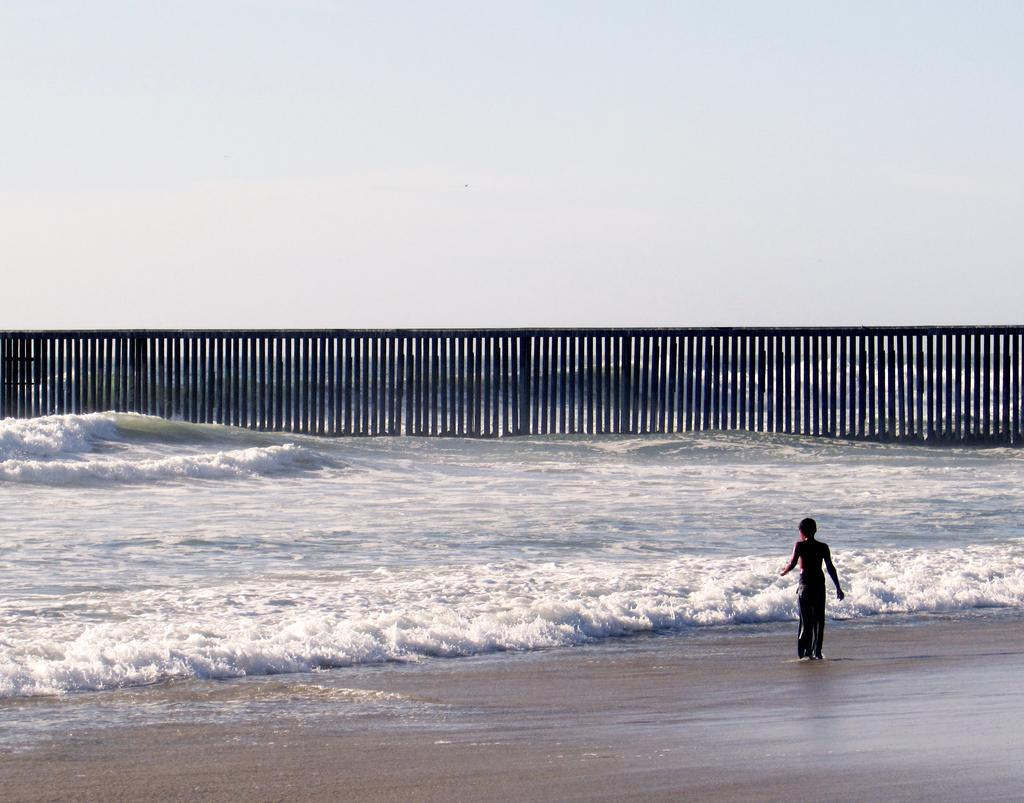Who or what is present in the image? There is a person in the image. What is the primary element visible in the image? There is water visible in the image. What type of barrier can be seen in the image? There is a fence in the image. What can be seen in the background of the image? The sky is visible in the background of the image. What type of wall is present in the image? There is no wall present in the image; it features a person, water, a fence, and the sky. 